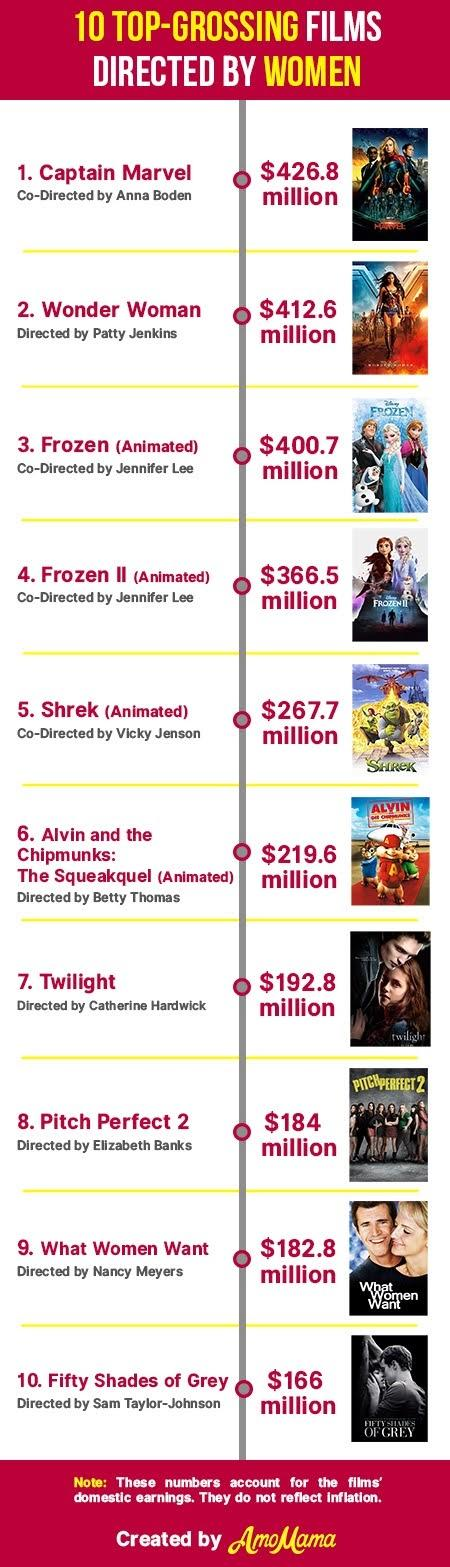Indicate a few pertinent items in this graphic. Four animation movies are present. There were two movies that were co-directed by Jennifer Lee. Nine women directors are listed in this table. Out of the animated movies produced, Disney produced two of them. 